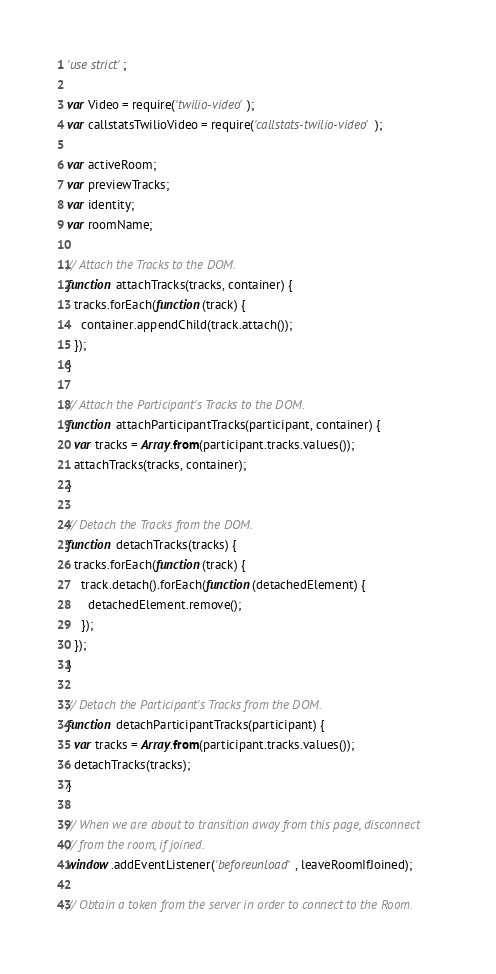<code> <loc_0><loc_0><loc_500><loc_500><_JavaScript_>'use strict';

var Video = require('twilio-video');
var callstatsTwilioVideo = require('callstats-twilio-video');

var activeRoom;
var previewTracks;
var identity;
var roomName;

// Attach the Tracks to the DOM.
function attachTracks(tracks, container) {
  tracks.forEach(function(track) {
    container.appendChild(track.attach());
  });
}

// Attach the Participant's Tracks to the DOM.
function attachParticipantTracks(participant, container) {
  var tracks = Array.from(participant.tracks.values());
  attachTracks(tracks, container);
}

// Detach the Tracks from the DOM.
function detachTracks(tracks) {
  tracks.forEach(function(track) {
    track.detach().forEach(function(detachedElement) {
      detachedElement.remove();
    });
  });
}

// Detach the Participant's Tracks from the DOM.
function detachParticipantTracks(participant) {
  var tracks = Array.from(participant.tracks.values());
  detachTracks(tracks);
}

// When we are about to transition away from this page, disconnect
// from the room, if joined.
window.addEventListener('beforeunload', leaveRoomIfJoined);

// Obtain a token from the server in order to connect to the Room.</code> 